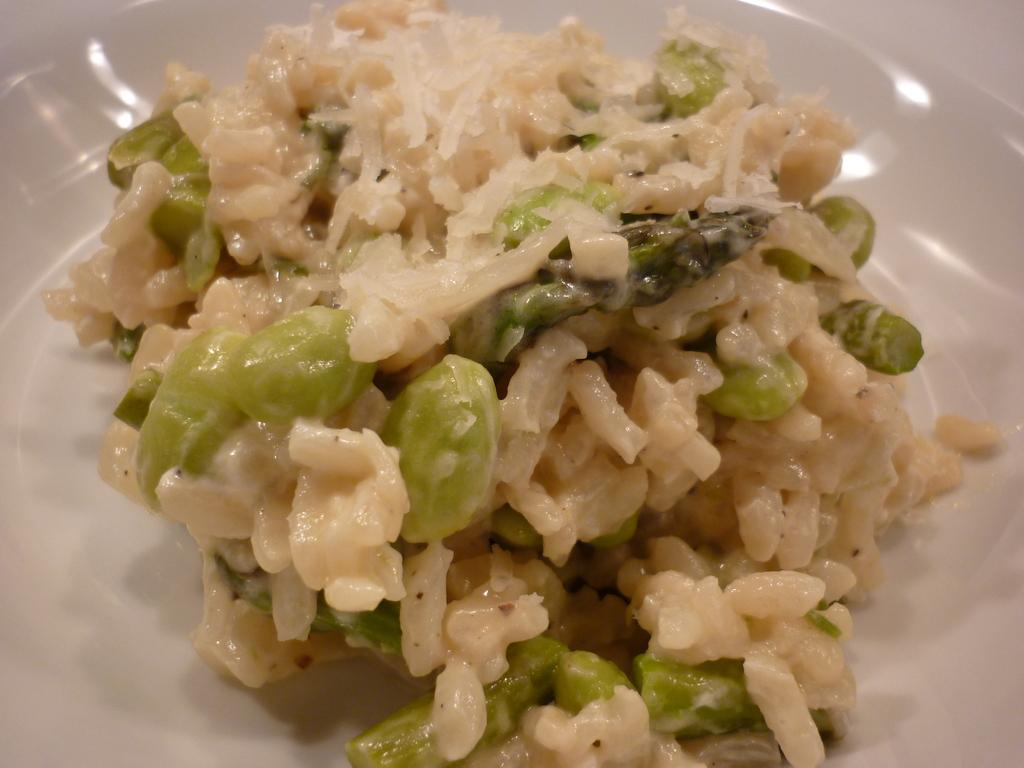What type of objects can be seen in the image? There are food items in the image. How are the food items arranged or presented? The food items are in a plate. Can you describe the setting where the plate is located? The plate may be on a table, and the image was taken in a room. How many feet can be seen in the image? There are no feet visible in the image. Is there an island in the image? There is no island present in the image. 